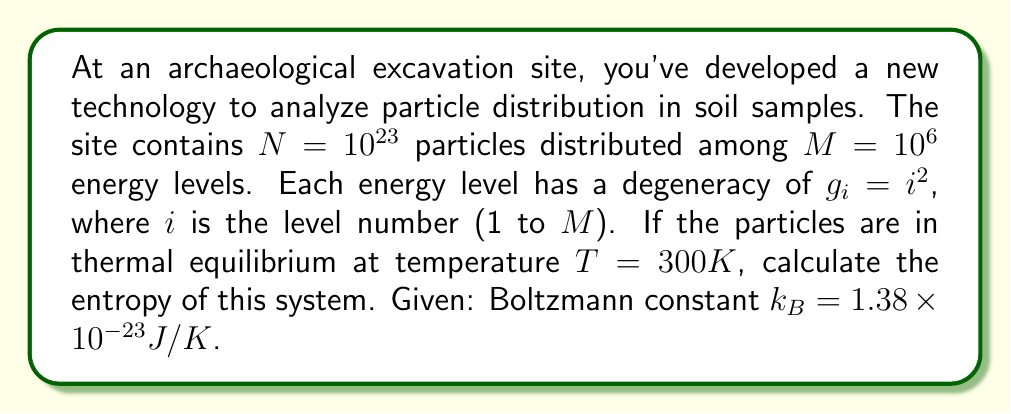Can you solve this math problem? To calculate the entropy of this system, we'll use the Boltzmann entropy formula:

$$ S = k_B \ln W $$

Where $W$ is the number of microstates.

Step 1: Calculate the partition function $Z$
$$ Z = \sum_{i=1}^M g_i e^{-\beta E_i} $$
Where $\beta = \frac{1}{k_B T}$ and $E_i$ is the energy of level $i$.

For simplicity, let's assume $E_i = i \epsilon$, where $\epsilon$ is a small energy unit.

$$ Z = \sum_{i=1}^{10^6} i^2 e^{-\beta i \epsilon} $$

Step 2: Calculate the probability of a particle being in state $i$
$$ p_i = \frac{g_i e^{-\beta E_i}}{Z} = \frac{i^2 e^{-\beta i \epsilon}}{Z} $$

Step 3: Calculate the entropy using the Gibbs entropy formula
$$ S = -N k_B \sum_{i=1}^M p_i \ln p_i $$

$$ S = -N k_B \sum_{i=1}^{10^6} \frac{i^2 e^{-\beta i \epsilon}}{Z} \ln \left(\frac{i^2 e^{-\beta i \epsilon}}{Z}\right) $$

$$ S = N k_B \left[\ln Z - \frac{1}{Z} \sum_{i=1}^{10^6} i^2 e^{-\beta i \epsilon} (\beta i \epsilon - 2 \ln i)\right] $$

Step 4: Substitute the values
$N = 10^{23}$
$k_B = 1.38 \times 10^{-23} J/K$
$T = 300K$

The final entropy value depends on the specific value of $\epsilon$, which wasn't given. However, the general form of the entropy for this system is:

$$ S = 1.38 \times 10^{-23} \times 10^{23} \times \left[\ln Z - \frac{1}{Z} \sum_{i=1}^{10^6} i^2 e^{-\beta i \epsilon} (\beta i \epsilon - 2 \ln i)\right] J/K $$
Answer: $S = 1.38 \left[\ln Z - \frac{1}{Z} \sum_{i=1}^{10^6} i^2 e^{-\beta i \epsilon} (\beta i \epsilon - 2 \ln i)\right] J/K$ 